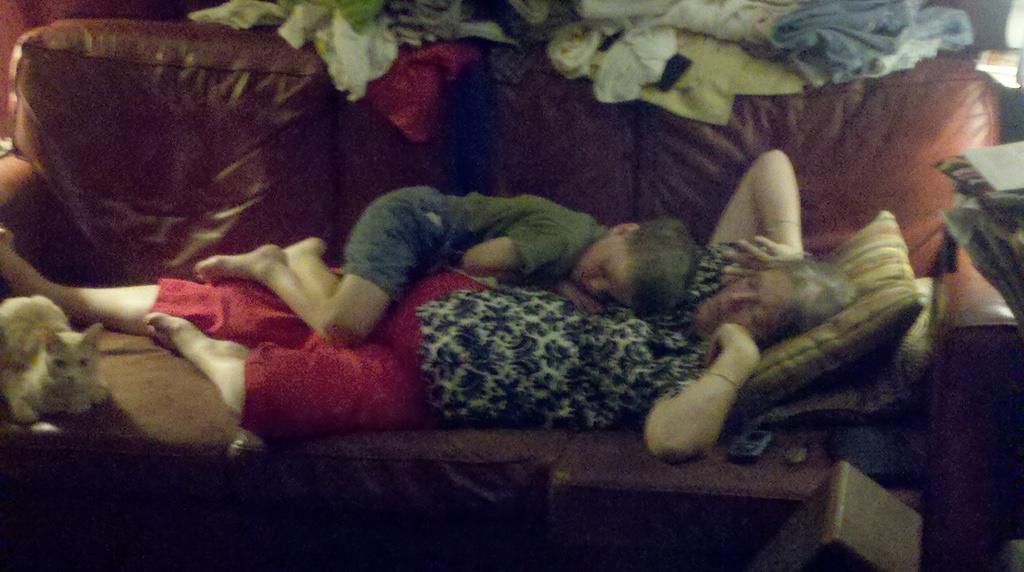Please provide a concise description of this image. In this picture we can see two people are lying on couch, around there are some clothes and we can see one cat sitting on the couch. 